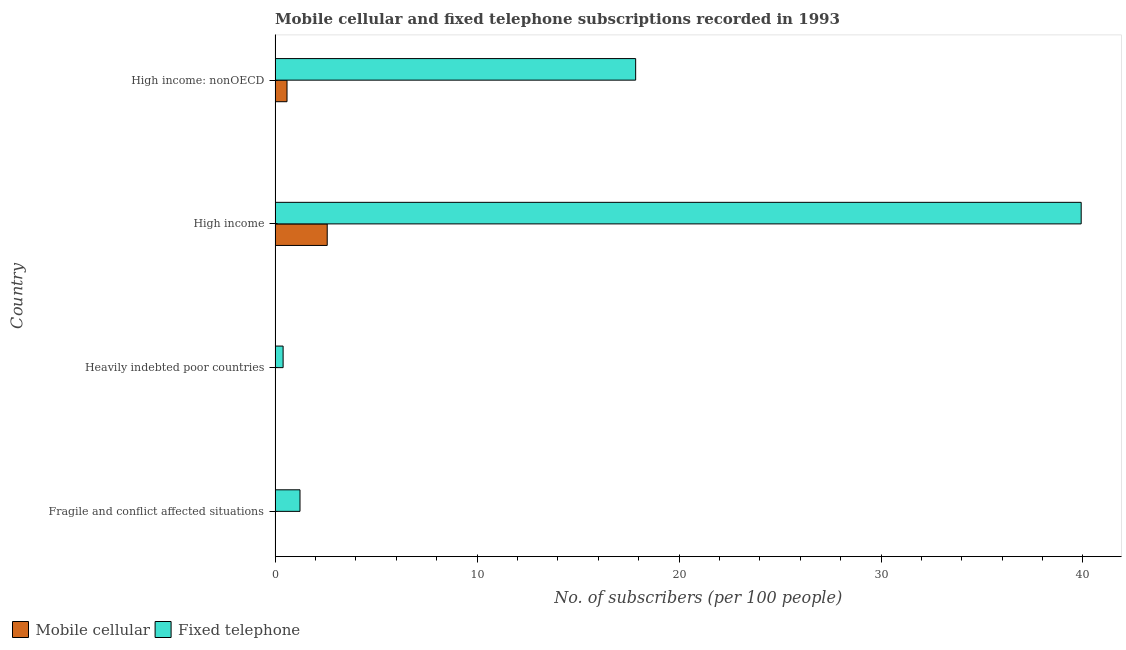How many groups of bars are there?
Make the answer very short. 4. How many bars are there on the 3rd tick from the top?
Your answer should be compact. 2. What is the label of the 3rd group of bars from the top?
Make the answer very short. Heavily indebted poor countries. In how many cases, is the number of bars for a given country not equal to the number of legend labels?
Offer a very short reply. 0. What is the number of fixed telephone subscribers in High income: nonOECD?
Provide a succinct answer. 17.85. Across all countries, what is the maximum number of mobile cellular subscribers?
Provide a succinct answer. 2.58. Across all countries, what is the minimum number of fixed telephone subscribers?
Keep it short and to the point. 0.4. In which country was the number of mobile cellular subscribers maximum?
Provide a short and direct response. High income. In which country was the number of mobile cellular subscribers minimum?
Ensure brevity in your answer.  Heavily indebted poor countries. What is the total number of mobile cellular subscribers in the graph?
Offer a very short reply. 3.18. What is the difference between the number of mobile cellular subscribers in Heavily indebted poor countries and that in High income?
Ensure brevity in your answer.  -2.58. What is the difference between the number of mobile cellular subscribers in High income and the number of fixed telephone subscribers in Fragile and conflict affected situations?
Your answer should be very brief. 1.35. What is the average number of fixed telephone subscribers per country?
Your answer should be compact. 14.85. What is the difference between the number of mobile cellular subscribers and number of fixed telephone subscribers in Fragile and conflict affected situations?
Your answer should be very brief. -1.23. What is the ratio of the number of fixed telephone subscribers in Fragile and conflict affected situations to that in High income?
Provide a short and direct response. 0.03. What is the difference between the highest and the second highest number of fixed telephone subscribers?
Keep it short and to the point. 22.06. What is the difference between the highest and the lowest number of mobile cellular subscribers?
Ensure brevity in your answer.  2.58. Is the sum of the number of mobile cellular subscribers in Heavily indebted poor countries and High income greater than the maximum number of fixed telephone subscribers across all countries?
Provide a succinct answer. No. What does the 2nd bar from the top in Heavily indebted poor countries represents?
Your response must be concise. Mobile cellular. What does the 1st bar from the bottom in High income represents?
Your answer should be very brief. Mobile cellular. Are all the bars in the graph horizontal?
Provide a succinct answer. Yes. How many countries are there in the graph?
Your answer should be compact. 4. Are the values on the major ticks of X-axis written in scientific E-notation?
Your answer should be very brief. No. Does the graph contain any zero values?
Your answer should be compact. No. Does the graph contain grids?
Your answer should be very brief. No. Where does the legend appear in the graph?
Provide a succinct answer. Bottom left. How are the legend labels stacked?
Provide a succinct answer. Horizontal. What is the title of the graph?
Provide a short and direct response. Mobile cellular and fixed telephone subscriptions recorded in 1993. What is the label or title of the X-axis?
Your response must be concise. No. of subscribers (per 100 people). What is the label or title of the Y-axis?
Ensure brevity in your answer.  Country. What is the No. of subscribers (per 100 people) in Mobile cellular in Fragile and conflict affected situations?
Offer a very short reply. 0. What is the No. of subscribers (per 100 people) of Fixed telephone in Fragile and conflict affected situations?
Your answer should be compact. 1.23. What is the No. of subscribers (per 100 people) of Mobile cellular in Heavily indebted poor countries?
Keep it short and to the point. 0. What is the No. of subscribers (per 100 people) of Fixed telephone in Heavily indebted poor countries?
Provide a succinct answer. 0.4. What is the No. of subscribers (per 100 people) of Mobile cellular in High income?
Provide a short and direct response. 2.58. What is the No. of subscribers (per 100 people) of Fixed telephone in High income?
Offer a very short reply. 39.91. What is the No. of subscribers (per 100 people) in Mobile cellular in High income: nonOECD?
Give a very brief answer. 0.59. What is the No. of subscribers (per 100 people) in Fixed telephone in High income: nonOECD?
Offer a terse response. 17.85. Across all countries, what is the maximum No. of subscribers (per 100 people) of Mobile cellular?
Give a very brief answer. 2.58. Across all countries, what is the maximum No. of subscribers (per 100 people) of Fixed telephone?
Your answer should be very brief. 39.91. Across all countries, what is the minimum No. of subscribers (per 100 people) in Mobile cellular?
Ensure brevity in your answer.  0. Across all countries, what is the minimum No. of subscribers (per 100 people) in Fixed telephone?
Offer a terse response. 0.4. What is the total No. of subscribers (per 100 people) in Mobile cellular in the graph?
Provide a short and direct response. 3.18. What is the total No. of subscribers (per 100 people) in Fixed telephone in the graph?
Keep it short and to the point. 59.4. What is the difference between the No. of subscribers (per 100 people) of Mobile cellular in Fragile and conflict affected situations and that in Heavily indebted poor countries?
Ensure brevity in your answer.  0. What is the difference between the No. of subscribers (per 100 people) in Fixed telephone in Fragile and conflict affected situations and that in Heavily indebted poor countries?
Your response must be concise. 0.84. What is the difference between the No. of subscribers (per 100 people) in Mobile cellular in Fragile and conflict affected situations and that in High income?
Offer a terse response. -2.58. What is the difference between the No. of subscribers (per 100 people) of Fixed telephone in Fragile and conflict affected situations and that in High income?
Offer a very short reply. -38.68. What is the difference between the No. of subscribers (per 100 people) of Mobile cellular in Fragile and conflict affected situations and that in High income: nonOECD?
Provide a succinct answer. -0.59. What is the difference between the No. of subscribers (per 100 people) in Fixed telephone in Fragile and conflict affected situations and that in High income: nonOECD?
Offer a very short reply. -16.62. What is the difference between the No. of subscribers (per 100 people) in Mobile cellular in Heavily indebted poor countries and that in High income?
Keep it short and to the point. -2.58. What is the difference between the No. of subscribers (per 100 people) of Fixed telephone in Heavily indebted poor countries and that in High income?
Your answer should be very brief. -39.51. What is the difference between the No. of subscribers (per 100 people) of Mobile cellular in Heavily indebted poor countries and that in High income: nonOECD?
Keep it short and to the point. -0.59. What is the difference between the No. of subscribers (per 100 people) of Fixed telephone in Heavily indebted poor countries and that in High income: nonOECD?
Keep it short and to the point. -17.46. What is the difference between the No. of subscribers (per 100 people) of Mobile cellular in High income and that in High income: nonOECD?
Provide a short and direct response. 1.99. What is the difference between the No. of subscribers (per 100 people) in Fixed telephone in High income and that in High income: nonOECD?
Offer a terse response. 22.06. What is the difference between the No. of subscribers (per 100 people) in Mobile cellular in Fragile and conflict affected situations and the No. of subscribers (per 100 people) in Fixed telephone in Heavily indebted poor countries?
Provide a short and direct response. -0.39. What is the difference between the No. of subscribers (per 100 people) of Mobile cellular in Fragile and conflict affected situations and the No. of subscribers (per 100 people) of Fixed telephone in High income?
Keep it short and to the point. -39.91. What is the difference between the No. of subscribers (per 100 people) in Mobile cellular in Fragile and conflict affected situations and the No. of subscribers (per 100 people) in Fixed telephone in High income: nonOECD?
Make the answer very short. -17.85. What is the difference between the No. of subscribers (per 100 people) of Mobile cellular in Heavily indebted poor countries and the No. of subscribers (per 100 people) of Fixed telephone in High income?
Keep it short and to the point. -39.91. What is the difference between the No. of subscribers (per 100 people) in Mobile cellular in Heavily indebted poor countries and the No. of subscribers (per 100 people) in Fixed telephone in High income: nonOECD?
Provide a short and direct response. -17.85. What is the difference between the No. of subscribers (per 100 people) of Mobile cellular in High income and the No. of subscribers (per 100 people) of Fixed telephone in High income: nonOECD?
Offer a very short reply. -15.27. What is the average No. of subscribers (per 100 people) in Mobile cellular per country?
Keep it short and to the point. 0.79. What is the average No. of subscribers (per 100 people) in Fixed telephone per country?
Make the answer very short. 14.85. What is the difference between the No. of subscribers (per 100 people) of Mobile cellular and No. of subscribers (per 100 people) of Fixed telephone in Fragile and conflict affected situations?
Provide a succinct answer. -1.23. What is the difference between the No. of subscribers (per 100 people) in Mobile cellular and No. of subscribers (per 100 people) in Fixed telephone in Heavily indebted poor countries?
Your answer should be very brief. -0.4. What is the difference between the No. of subscribers (per 100 people) of Mobile cellular and No. of subscribers (per 100 people) of Fixed telephone in High income?
Offer a very short reply. -37.33. What is the difference between the No. of subscribers (per 100 people) of Mobile cellular and No. of subscribers (per 100 people) of Fixed telephone in High income: nonOECD?
Ensure brevity in your answer.  -17.26. What is the ratio of the No. of subscribers (per 100 people) in Mobile cellular in Fragile and conflict affected situations to that in Heavily indebted poor countries?
Your response must be concise. 1.48. What is the ratio of the No. of subscribers (per 100 people) of Fixed telephone in Fragile and conflict affected situations to that in Heavily indebted poor countries?
Your response must be concise. 3.1. What is the ratio of the No. of subscribers (per 100 people) in Mobile cellular in Fragile and conflict affected situations to that in High income?
Ensure brevity in your answer.  0. What is the ratio of the No. of subscribers (per 100 people) in Fixed telephone in Fragile and conflict affected situations to that in High income?
Provide a succinct answer. 0.03. What is the ratio of the No. of subscribers (per 100 people) of Mobile cellular in Fragile and conflict affected situations to that in High income: nonOECD?
Keep it short and to the point. 0. What is the ratio of the No. of subscribers (per 100 people) in Fixed telephone in Fragile and conflict affected situations to that in High income: nonOECD?
Offer a very short reply. 0.07. What is the ratio of the No. of subscribers (per 100 people) in Mobile cellular in Heavily indebted poor countries to that in High income?
Provide a short and direct response. 0. What is the ratio of the No. of subscribers (per 100 people) in Mobile cellular in Heavily indebted poor countries to that in High income: nonOECD?
Your response must be concise. 0. What is the ratio of the No. of subscribers (per 100 people) in Fixed telephone in Heavily indebted poor countries to that in High income: nonOECD?
Offer a very short reply. 0.02. What is the ratio of the No. of subscribers (per 100 people) of Mobile cellular in High income to that in High income: nonOECD?
Provide a short and direct response. 4.37. What is the ratio of the No. of subscribers (per 100 people) in Fixed telephone in High income to that in High income: nonOECD?
Your answer should be compact. 2.24. What is the difference between the highest and the second highest No. of subscribers (per 100 people) of Mobile cellular?
Your answer should be compact. 1.99. What is the difference between the highest and the second highest No. of subscribers (per 100 people) of Fixed telephone?
Your answer should be compact. 22.06. What is the difference between the highest and the lowest No. of subscribers (per 100 people) in Mobile cellular?
Keep it short and to the point. 2.58. What is the difference between the highest and the lowest No. of subscribers (per 100 people) in Fixed telephone?
Provide a succinct answer. 39.51. 